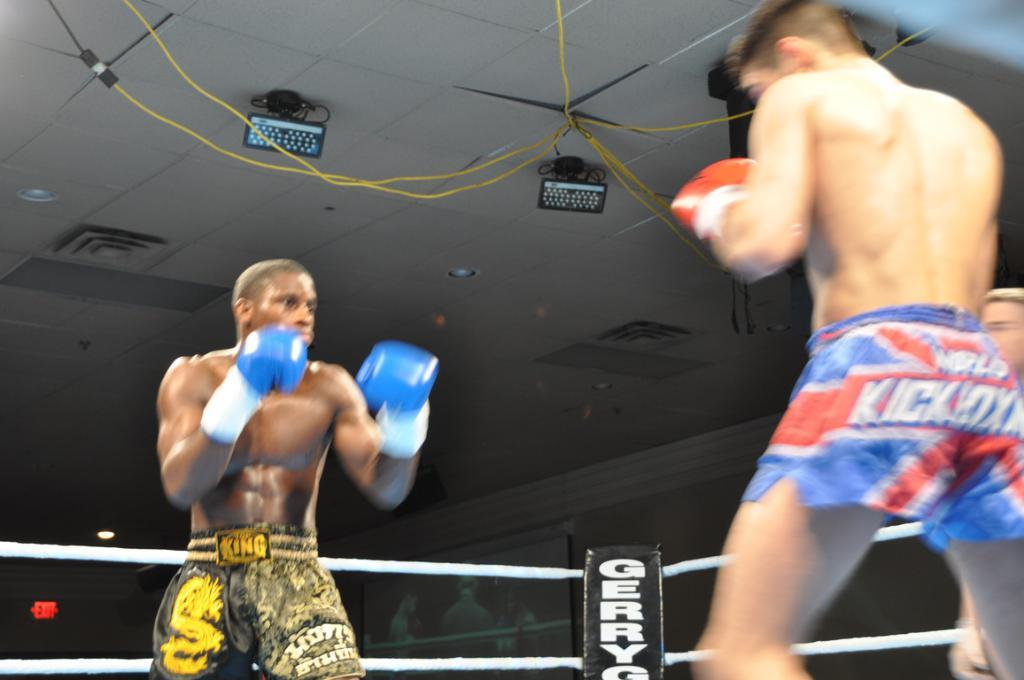<image>
Describe the image concisely. one of the boxer in the ring is wearing kickboxing shorts 